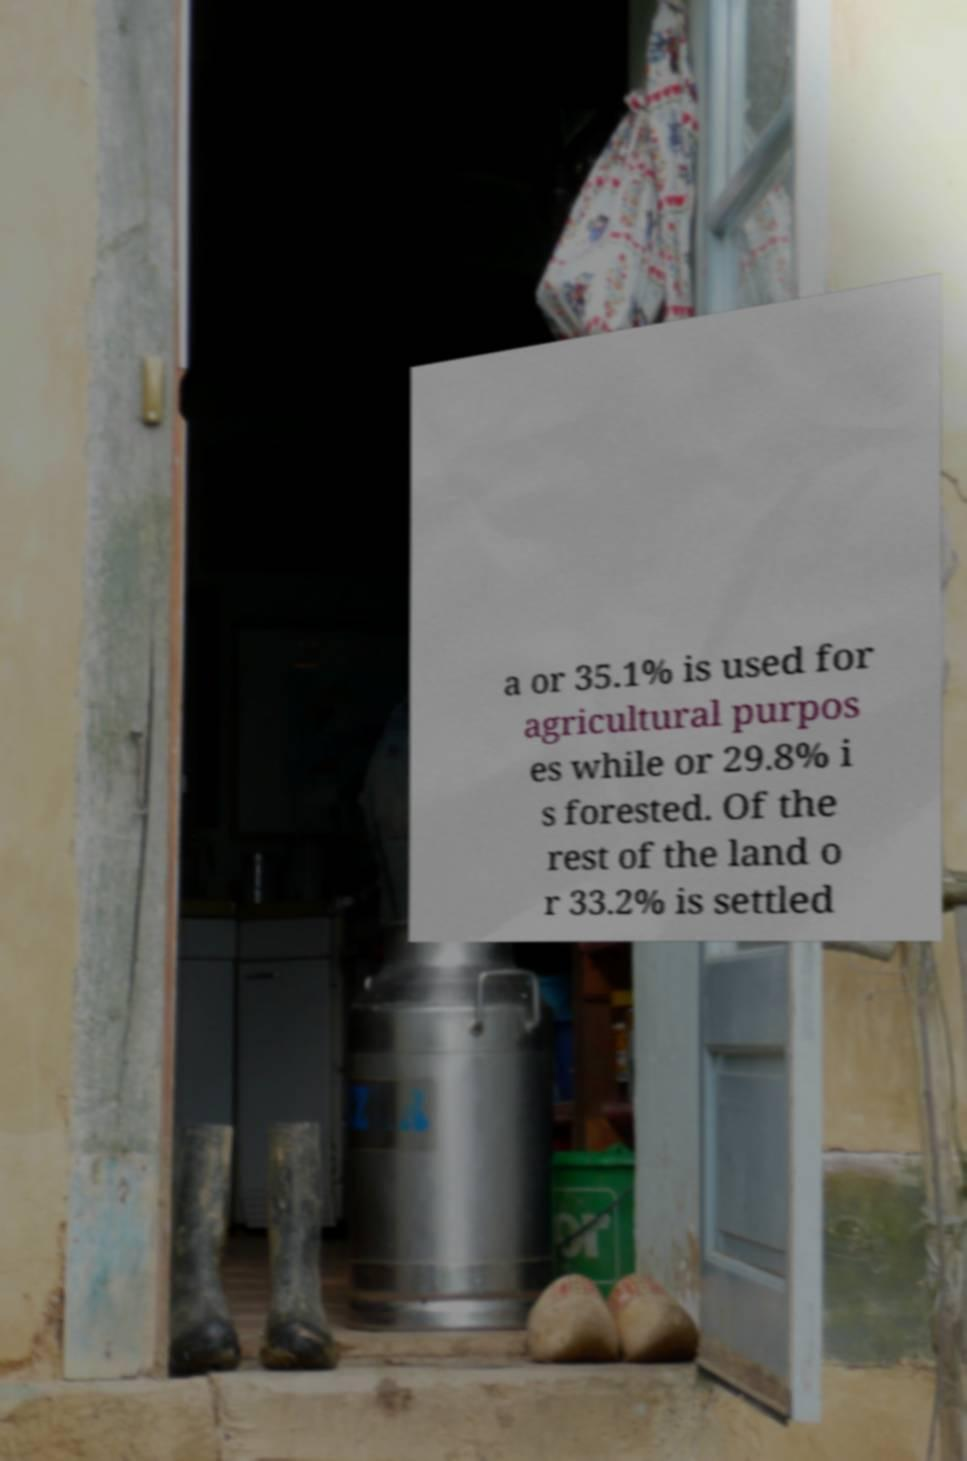I need the written content from this picture converted into text. Can you do that? a or 35.1% is used for agricultural purpos es while or 29.8% i s forested. Of the rest of the land o r 33.2% is settled 